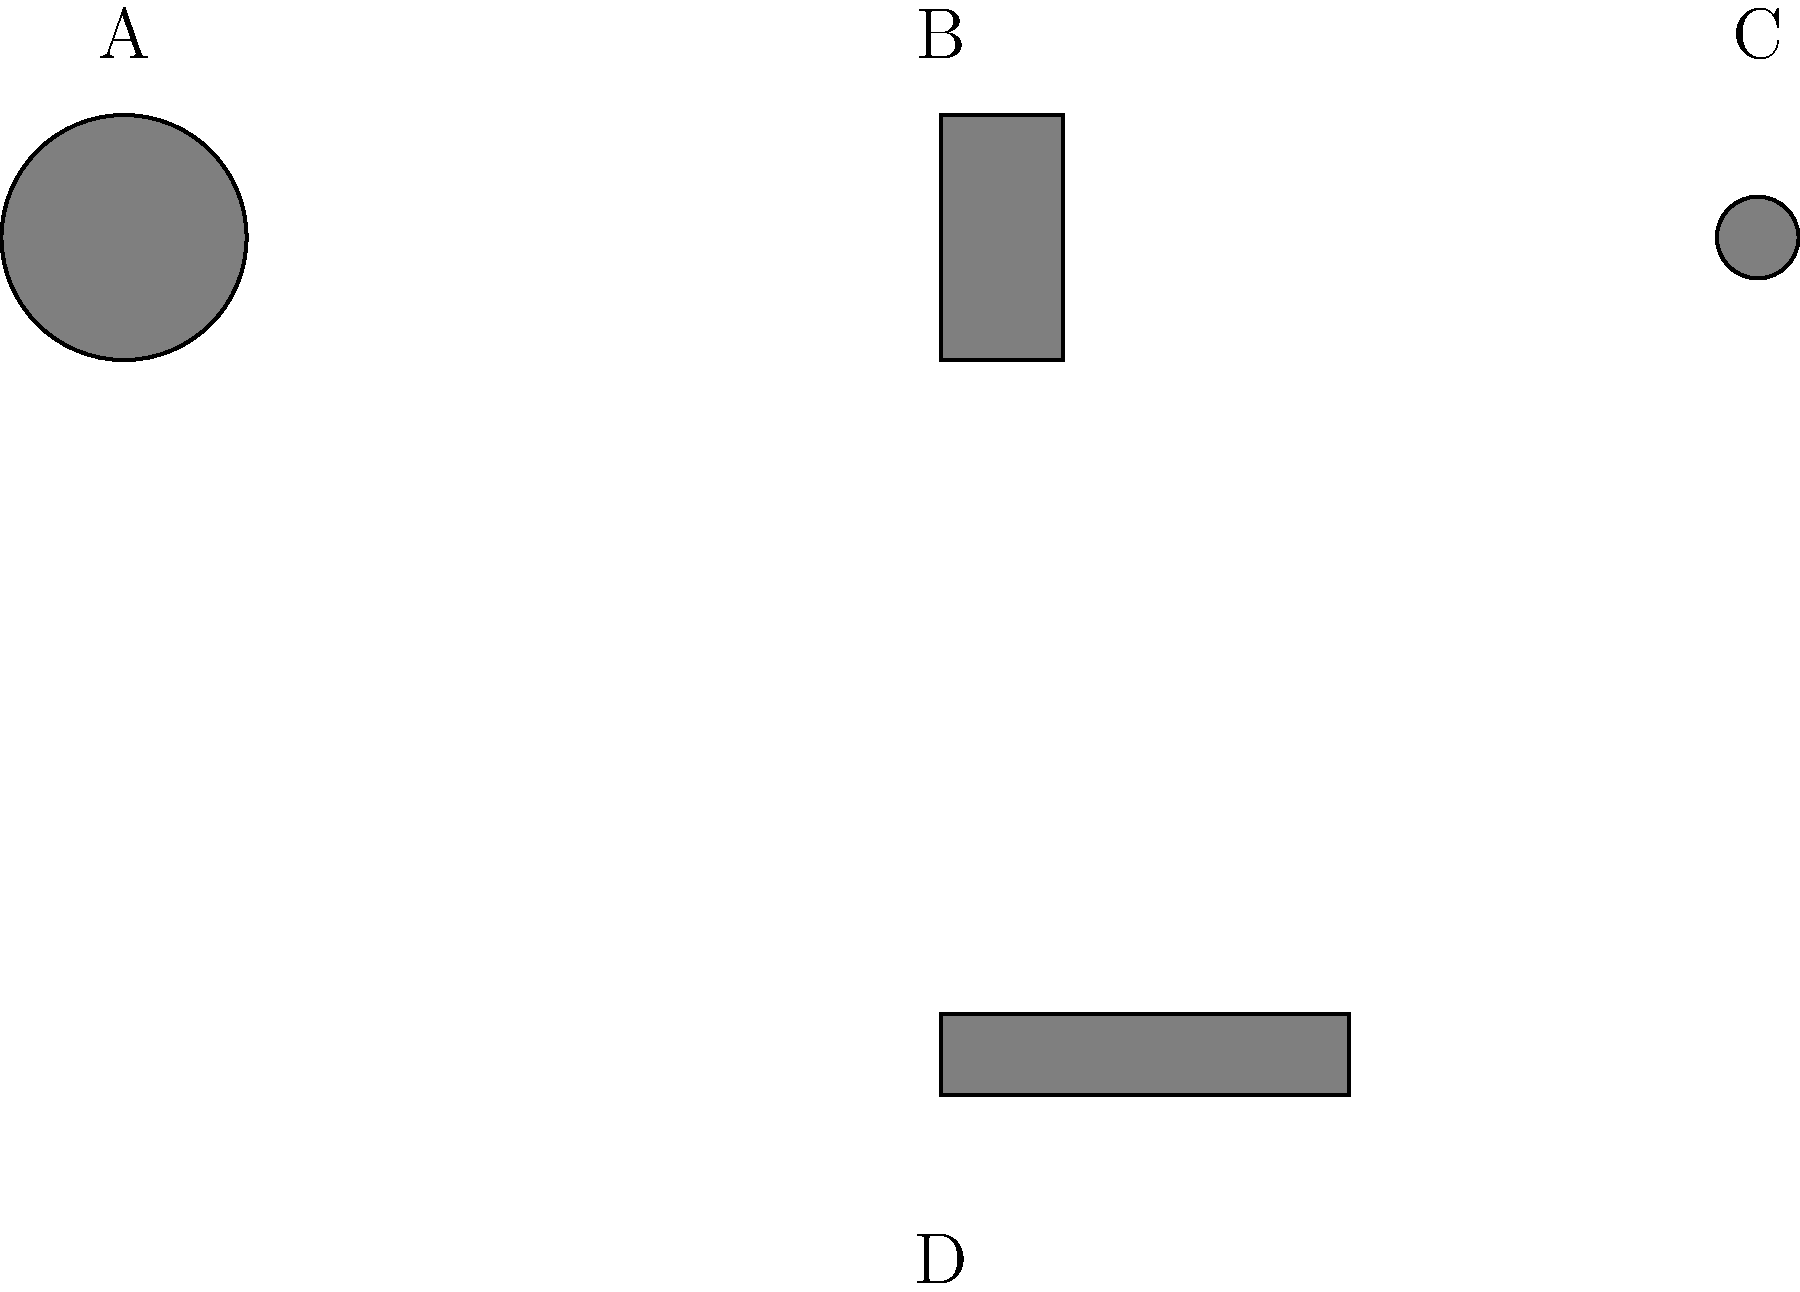As a budding comedian and fan of Jozef Pročko, you're familiar with various microphones used in stand-up comedy. Which of the illustrated microphones (A, B, C, or D) is most commonly used by stand-up comedians for its versatility and ease of handling during performances? Let's analyze each microphone type illustrated:

1. Microphone A: This circular shape represents a handheld microphone. It's the most common type used in stand-up comedy due to its versatility and ease of use. Comedians can easily move it around, adjust its distance from their mouth, and even use it as a prop if needed.

2. Microphone B: This shape represents a headset microphone. While useful for hands-free operation, it's less common in stand-up comedy as it limits facial expressions and can be distracting.

3. Microphone C: This small circular shape represents a lavalier or lapel microphone. These are typically used in interviews or TV shows but are rarely used in stand-up comedy as they can pick up clothing rustles and limit movement.

4. Microphone D: This elongated shape represents a shotgun microphone. These are primarily used for recording audio at a distance, such as in film production, and are not typically used for stand-up comedy performances.

Given the context of stand-up comedy and the need for versatility, the handheld microphone (A) is the most commonly used option for comedians, including those who might be influenced by Jozef Pročko's style.
Answer: A 